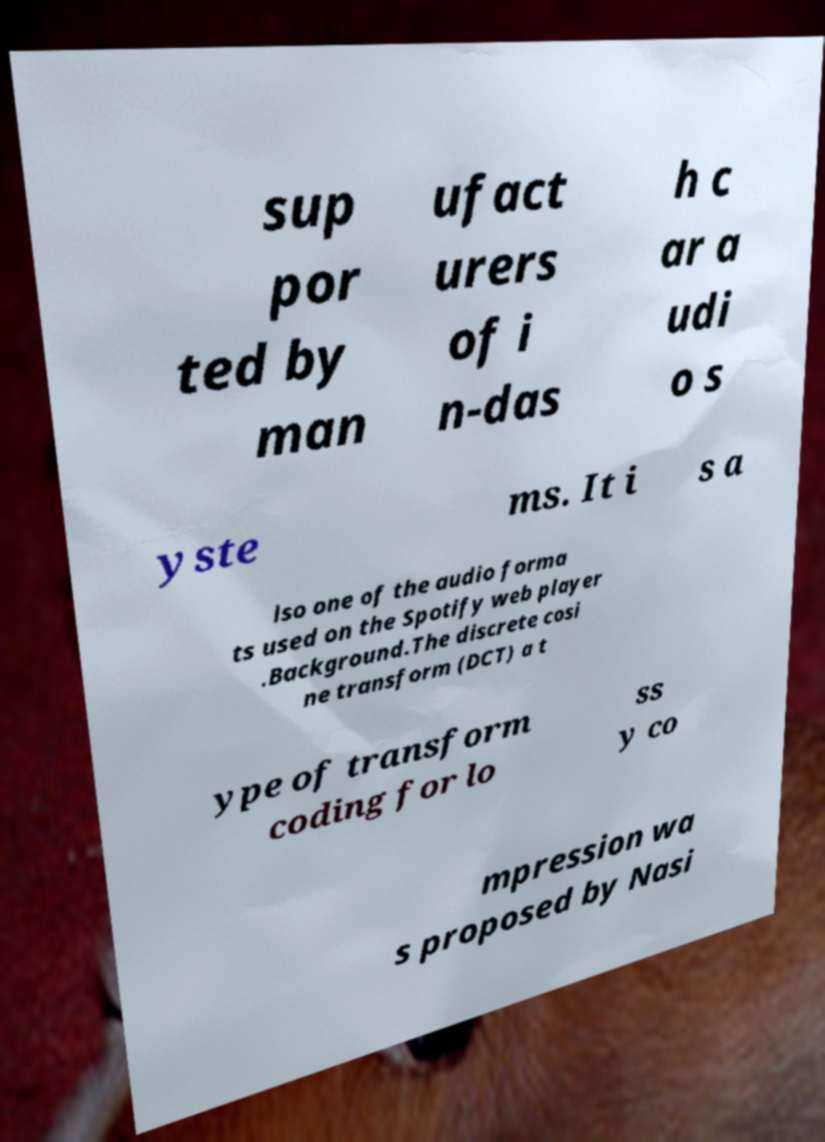I need the written content from this picture converted into text. Can you do that? sup por ted by man ufact urers of i n-das h c ar a udi o s yste ms. It i s a lso one of the audio forma ts used on the Spotify web player .Background.The discrete cosi ne transform (DCT) a t ype of transform coding for lo ss y co mpression wa s proposed by Nasi 